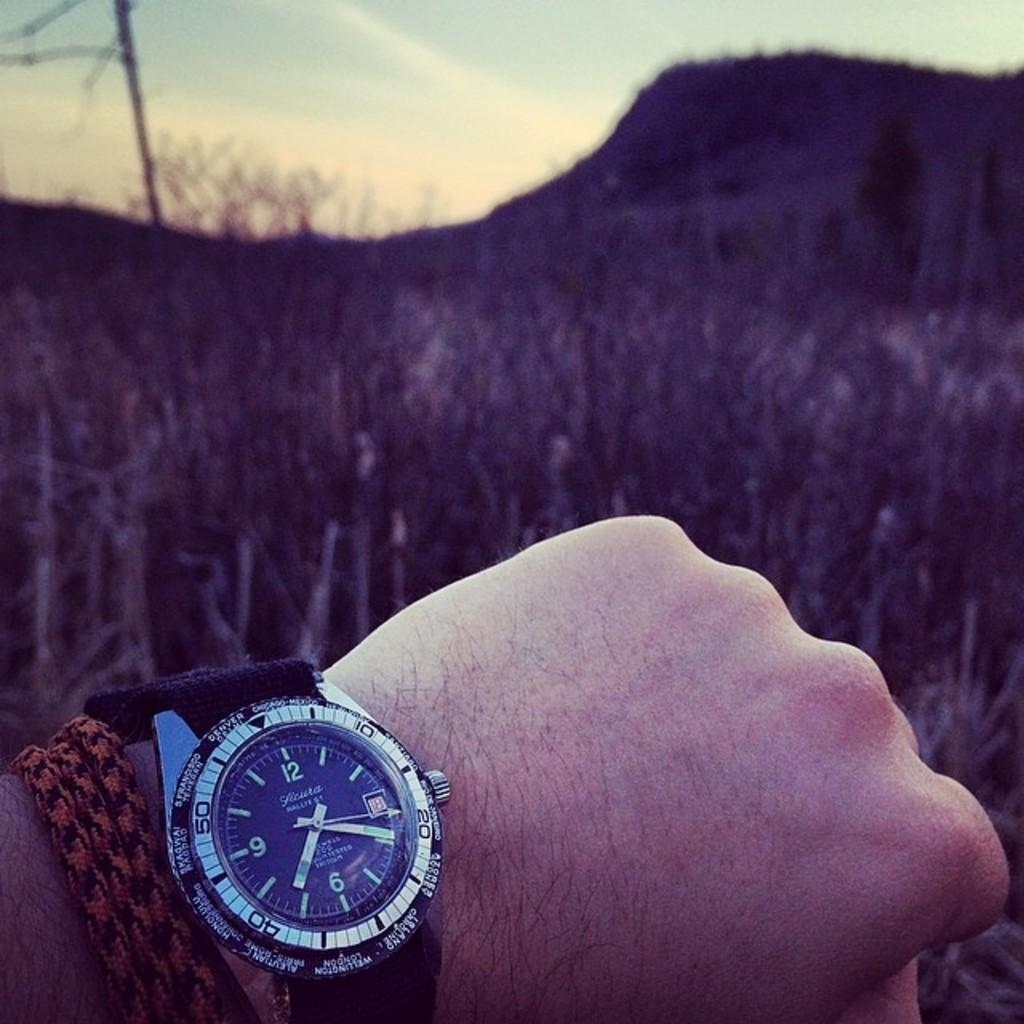<image>
Give a short and clear explanation of the subsequent image. The watch the person is wearing has the cities Denver and Chicago on it. 